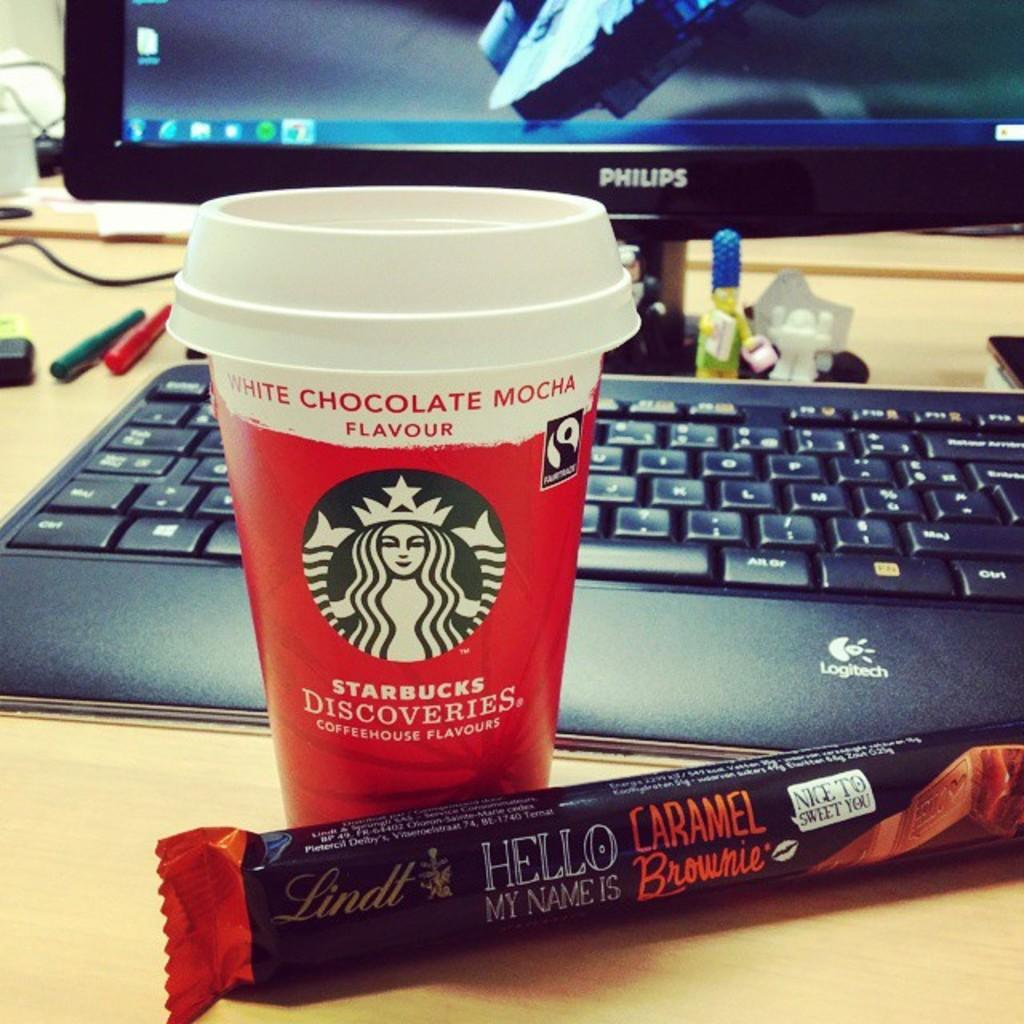What type of electronic device is visible in the image? There is a monitor in the image. What is used for input with the monitor? There is a keyboard in the image. What is the main processing unit for the computer system? There is a CPU in the image. What type of snack can be seen on the table in the image? There is a chocolate on the table in the image. What writing instruments are present in the image? There are two pens in the image. What connects the devices in the image? There are cables on the table in the image. What type of dock is visible in the image? There is no dock present in the image. Can you describe the bridge in the image? There is no bridge present in the image. 